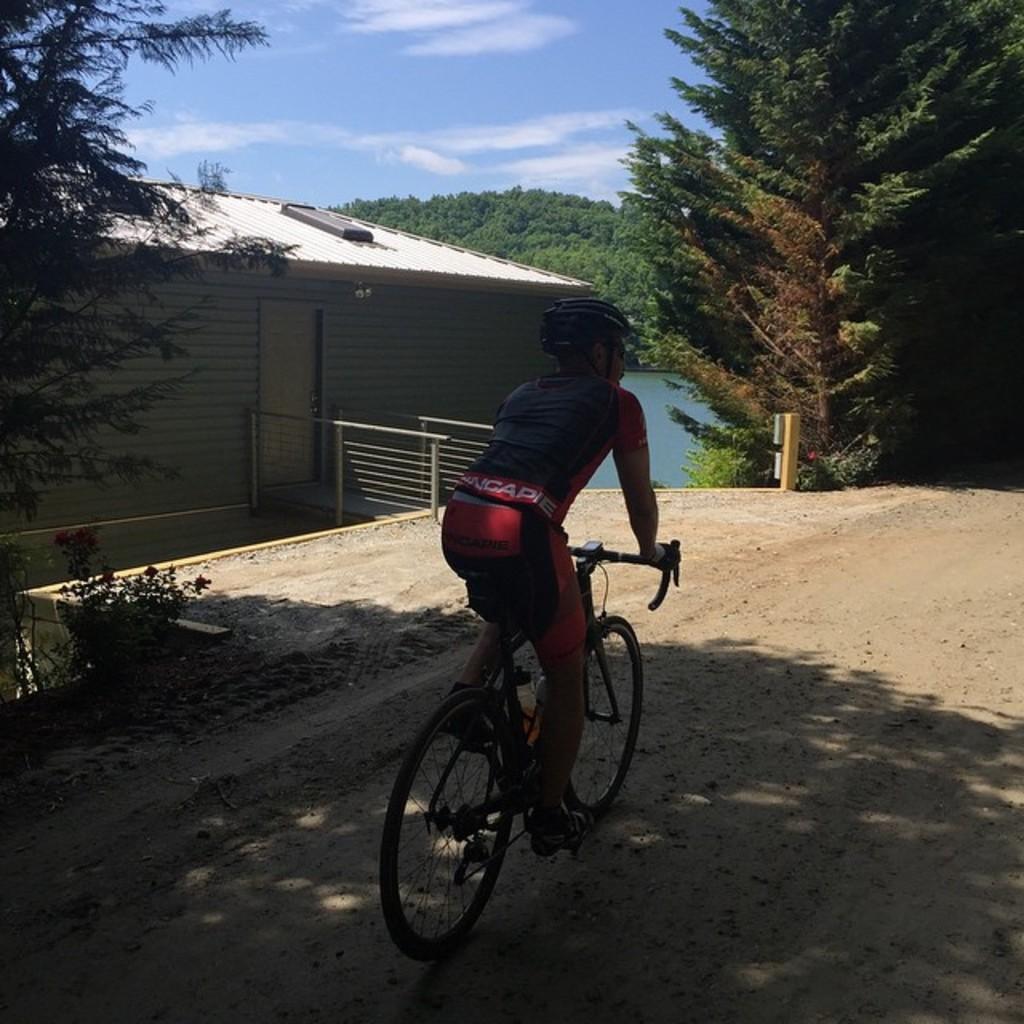How would you summarize this image in a sentence or two? In this image I can see a person is riding bicycle and wearing helmet. I can see a house,door,railing,trees and water. The sky is in white and blue color. 